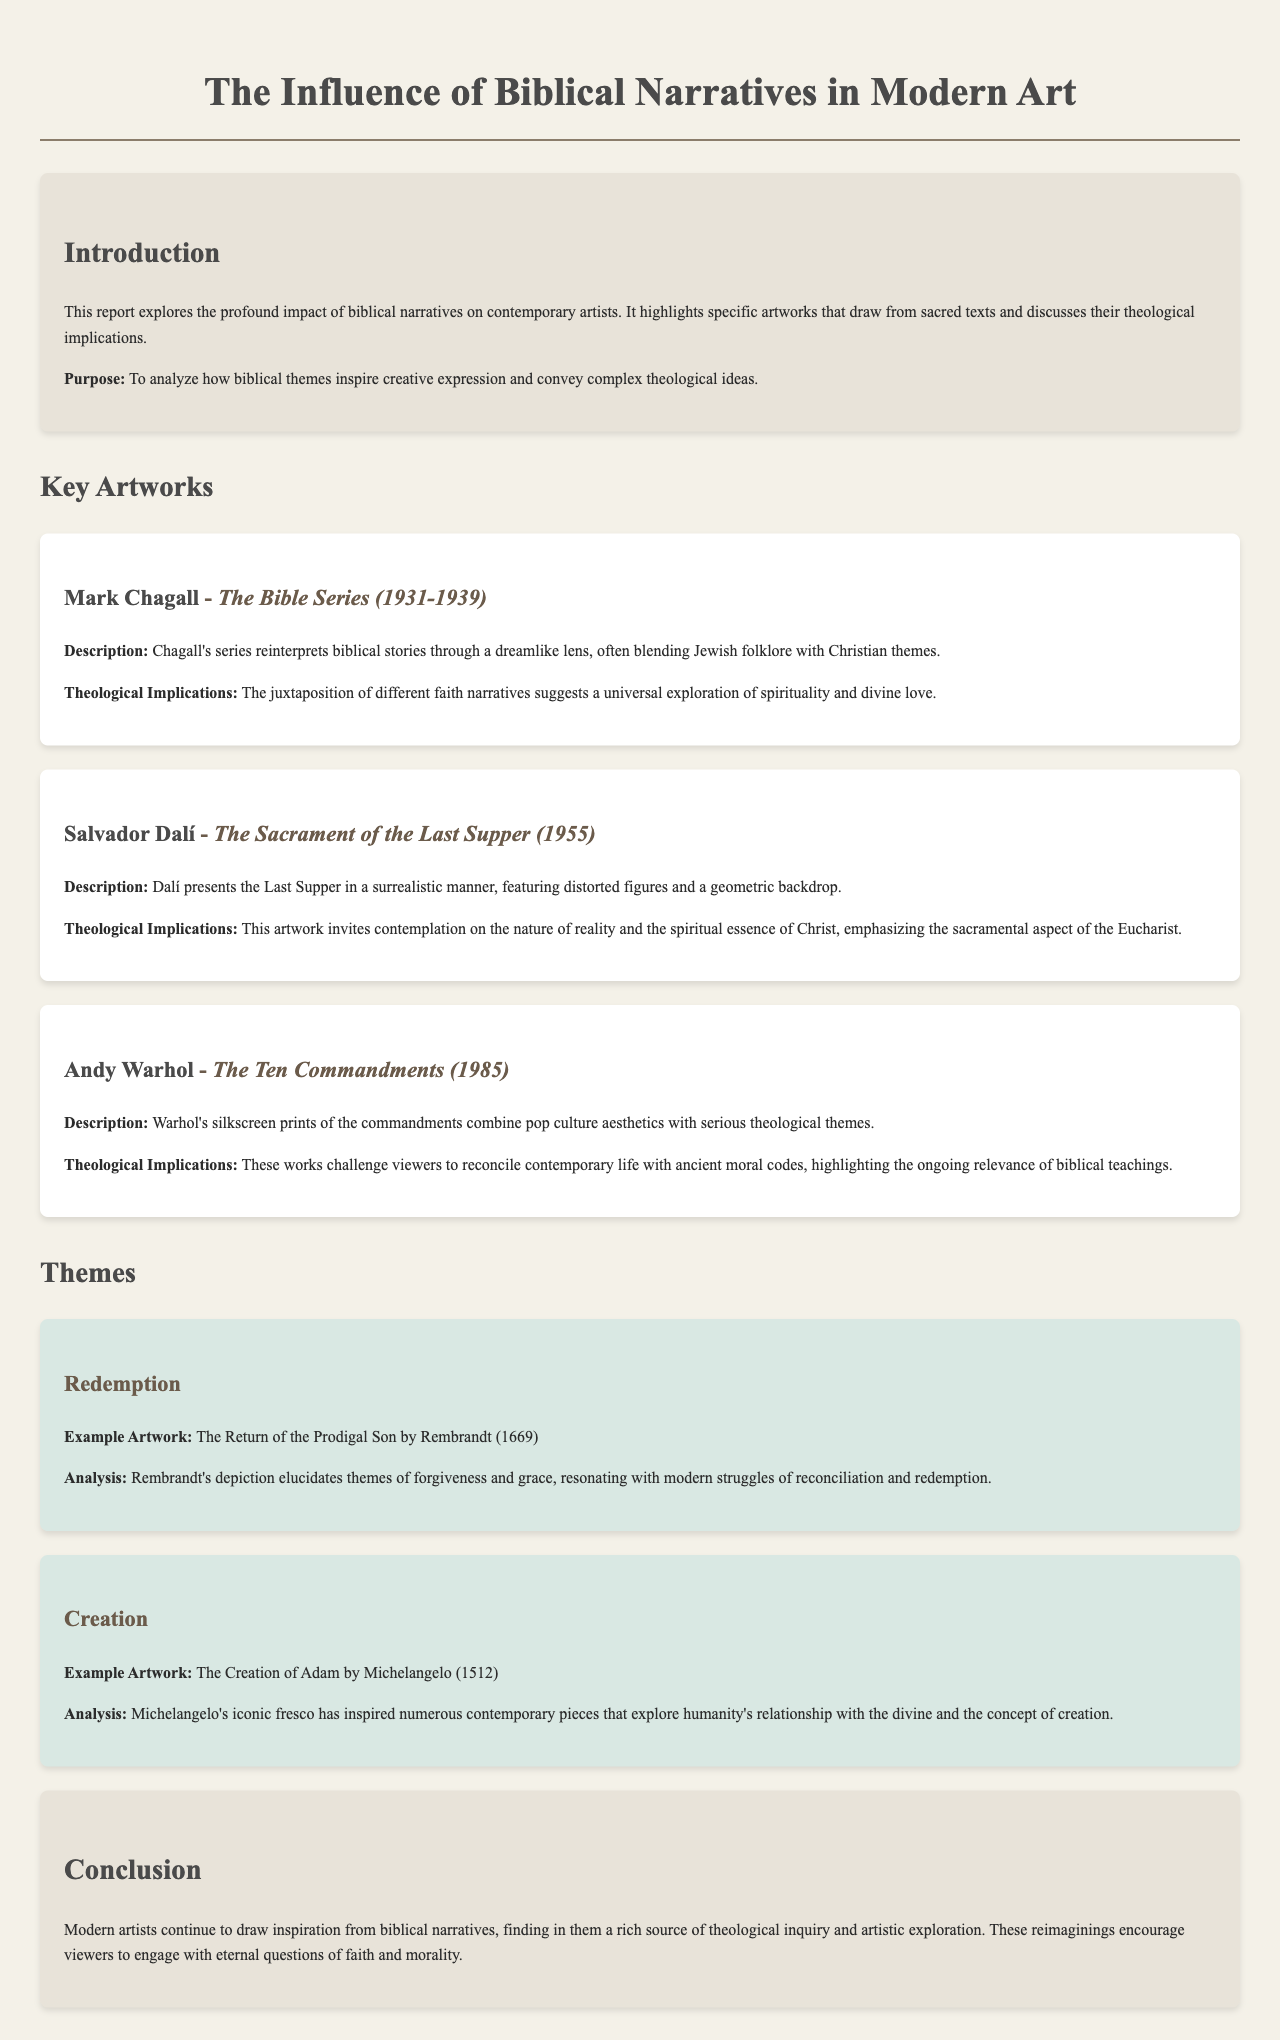What is the title of the report? The title of the report is prominently displayed at the top of the document.
Answer: The Influence of Biblical Narratives in Modern Art Who is the artist of "The Sacrament of the Last Supper"? The document mentions the artist next to the title of the artwork.
Answer: Salvador Dalí In what year was "The Ten Commandments" created? The year is referenced in the description of the specific artwork by Warhol.
Answer: 1985 What biblical theme does Rembrandt's "The Return of the Prodigal Son" illustrate? The document describes the theme associated with this particular artwork.
Answer: Redemption What describes Mark Chagall's interpretation of biblical stories? The document outlines the manner in which Chagall approaches the narratives.
Answer: Dreamlike lens What theological theme does Warhol's artworks challenge viewers to reconcile? This theme is directly linked to the analysis of Warhol’s silkscreen prints.
Answer: Ancient moral codes What style does Salvador Dalí use in "The Sacrament of the Last Supper"? The document discusses the artistic style presented in this work.
Answer: Surrealistic Which biblical figure is featured in Michelangelo's artwork that explores creation? The specific figure associated with the artwork is mentioned in the analysis.
Answer: Adam What is the conclusion of the report about modern artists' inspiration? The conclusion summarizes the overall findings and implications of the report.
Answer: Drawing inspiration from biblical narratives 